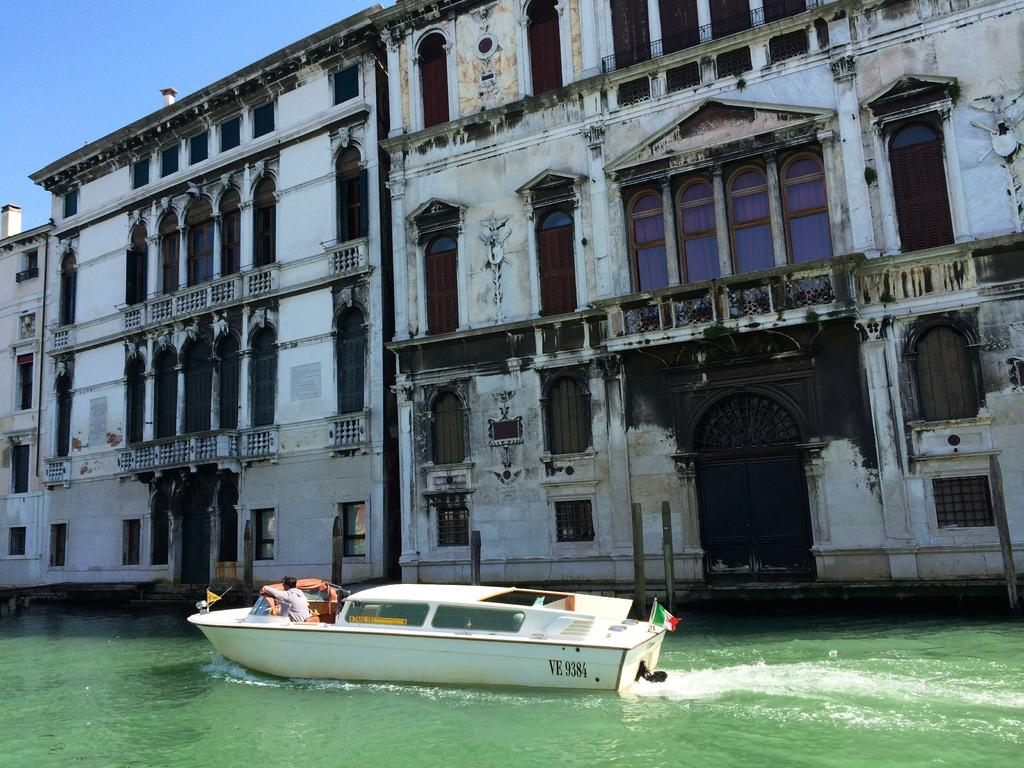<image>
Summarize the visual content of the image. A boat that has VE 9384 is cruising through the canal. 